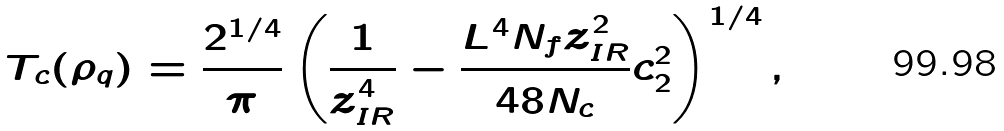Convert formula to latex. <formula><loc_0><loc_0><loc_500><loc_500>T _ { c } ( \rho _ { q } ) = \frac { 2 ^ { 1 / 4 } } { \pi } \left ( \frac { 1 } { z _ { I R } ^ { 4 } } - \frac { L ^ { 4 } N _ { f } z ^ { 2 } _ { I R } } { 4 8 N _ { c } } c ^ { 2 } _ { 2 } \right ) ^ { 1 / 4 } ,</formula> 